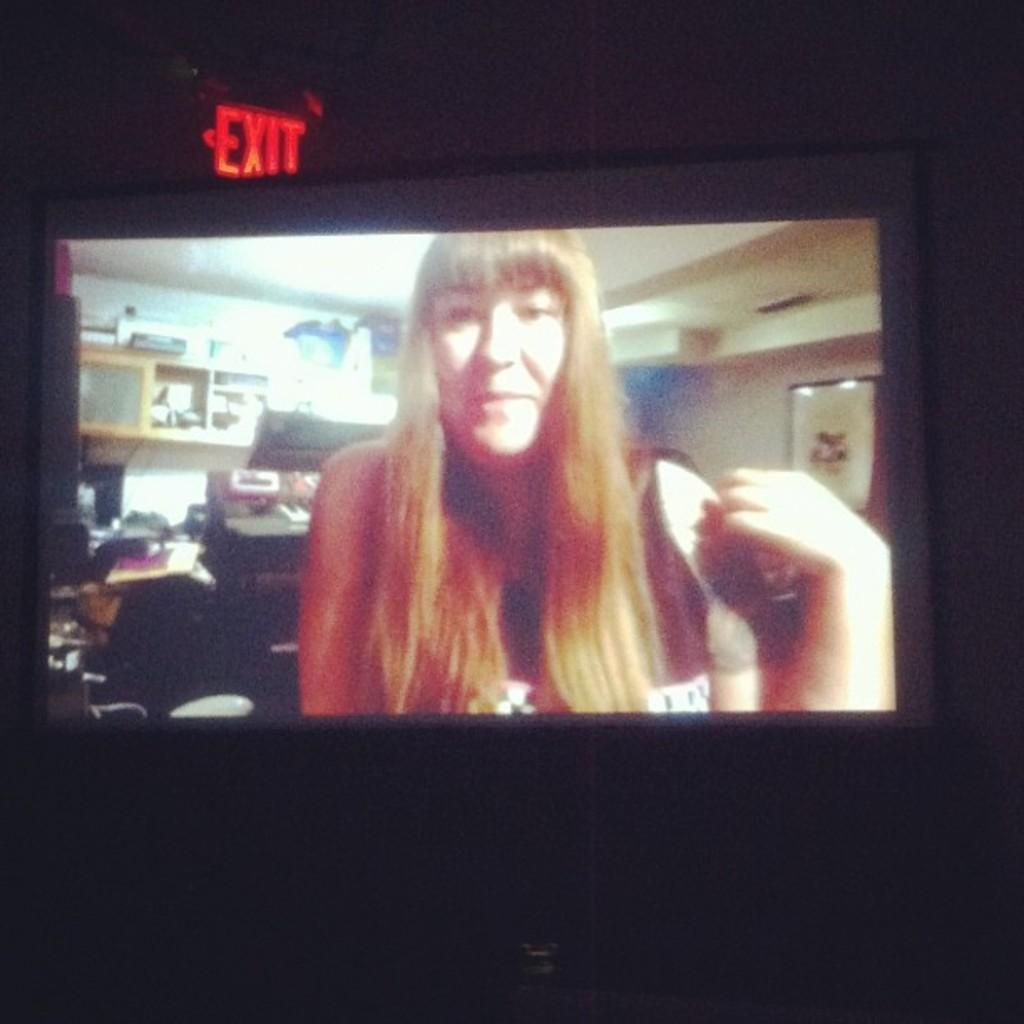<image>
Describe the image concisely. A projection screen shows a woman, just below an exit sign. 